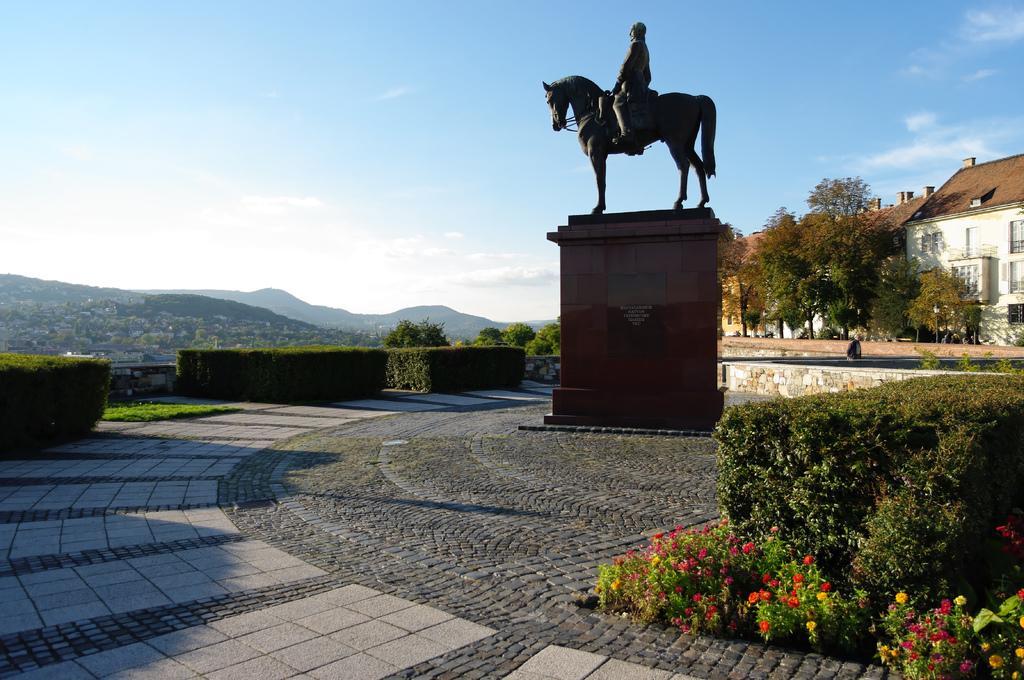Could you give a brief overview of what you see in this image? In the image we can see there is a statue of a person sitting on the horse statue. There are bushes and there are flowers on the plants. Behind there are trees and there are buildings. There are hills at the back and there is clear sky. 